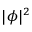Convert formula to latex. <formula><loc_0><loc_0><loc_500><loc_500>| \phi | ^ { 2 }</formula> 